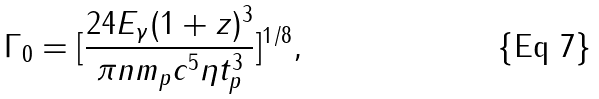Convert formula to latex. <formula><loc_0><loc_0><loc_500><loc_500>\Gamma _ { 0 } = [ \frac { 2 4 E _ { \gamma } ( 1 + z ) ^ { 3 } } { \pi n m _ { p } c ^ { 5 } \eta t _ { p } ^ { 3 } } ] ^ { 1 / 8 } ,</formula> 